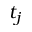<formula> <loc_0><loc_0><loc_500><loc_500>t _ { j }</formula> 